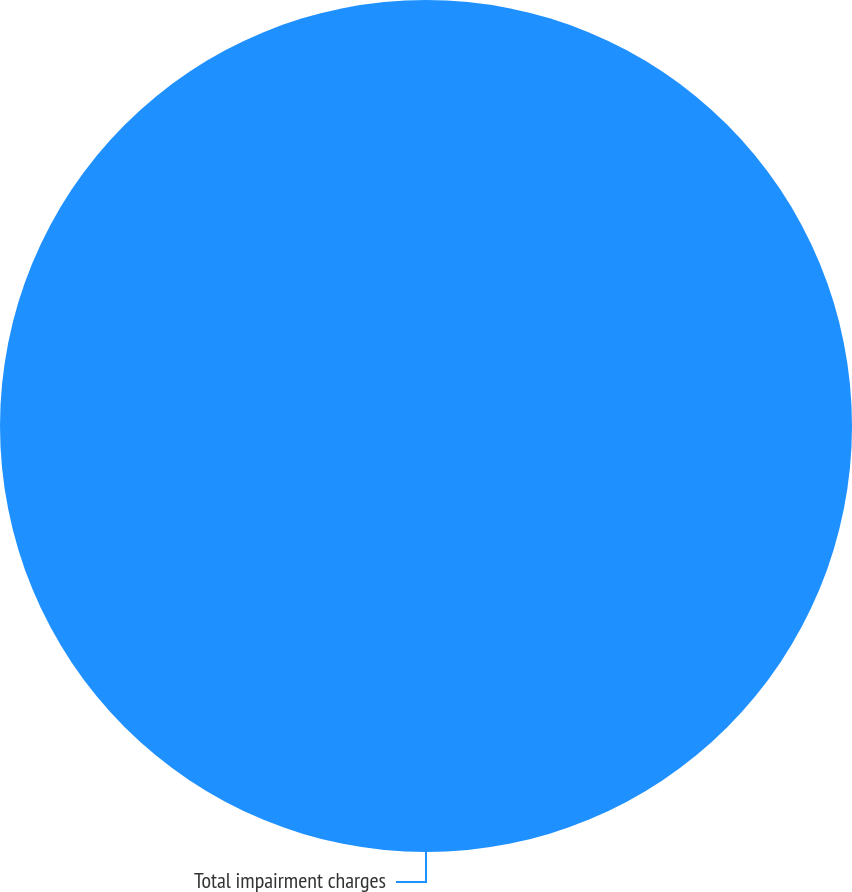Convert chart. <chart><loc_0><loc_0><loc_500><loc_500><pie_chart><fcel>Total impairment charges<nl><fcel>100.0%<nl></chart> 